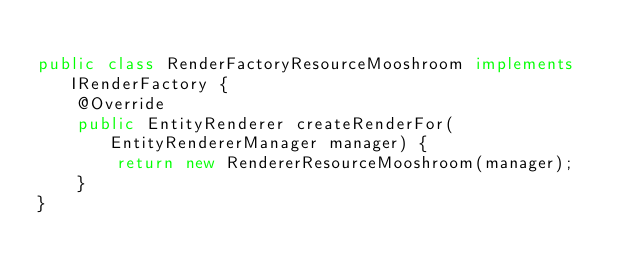Convert code to text. <code><loc_0><loc_0><loc_500><loc_500><_Java_>
public class RenderFactoryResourceMooshroom implements IRenderFactory {
    @Override
    public EntityRenderer createRenderFor(EntityRendererManager manager) {
        return new RendererResourceMooshroom(manager);
    }
}
</code> 